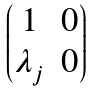<formula> <loc_0><loc_0><loc_500><loc_500>\begin{pmatrix} 1 & 0 \\ \lambda _ { j } & 0 \end{pmatrix}</formula> 